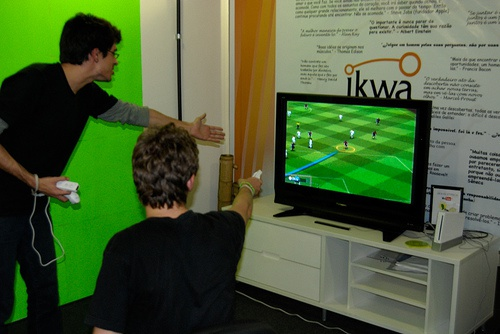Describe the objects in this image and their specific colors. I can see people in lime, black, maroon, and darkgreen tones, people in lime, black, olive, and gray tones, tv in lime, black, green, and darkgreen tones, remote in lime, darkgray, gray, green, and lightgray tones, and remote in lime, darkgray, and gray tones in this image. 